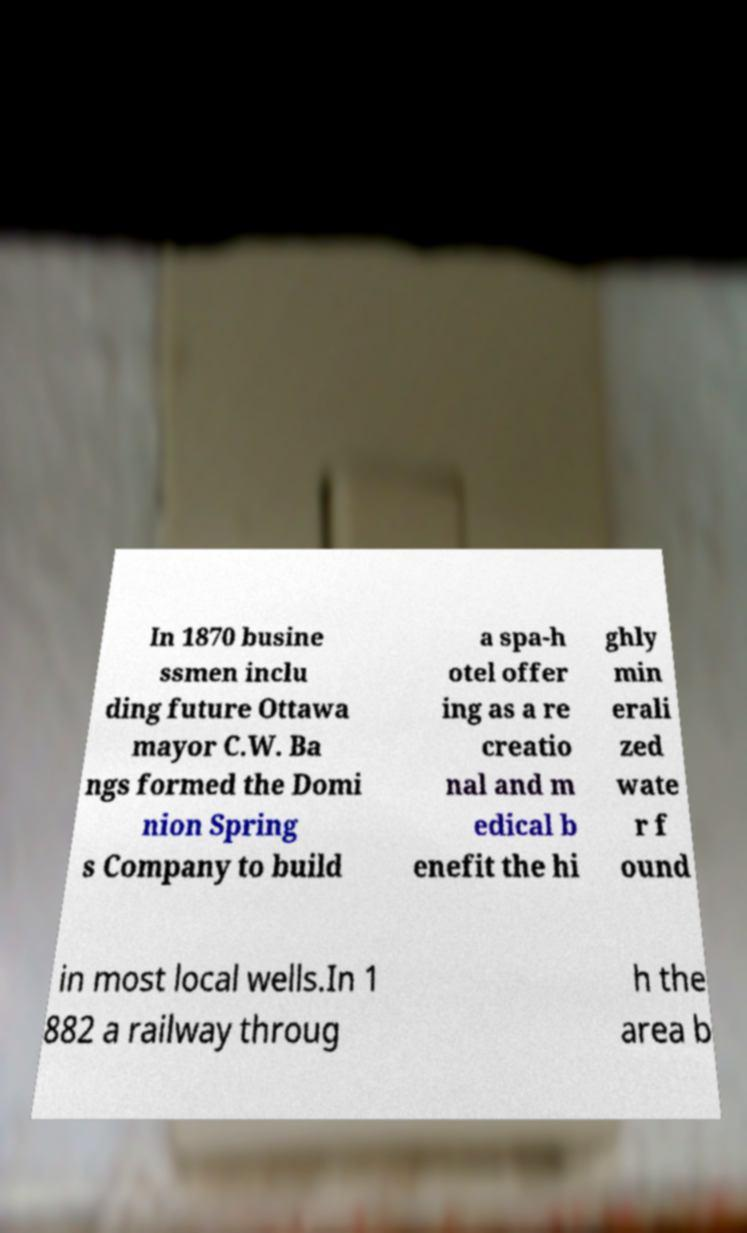Can you read and provide the text displayed in the image?This photo seems to have some interesting text. Can you extract and type it out for me? In 1870 busine ssmen inclu ding future Ottawa mayor C.W. Ba ngs formed the Domi nion Spring s Company to build a spa-h otel offer ing as a re creatio nal and m edical b enefit the hi ghly min erali zed wate r f ound in most local wells.In 1 882 a railway throug h the area b 